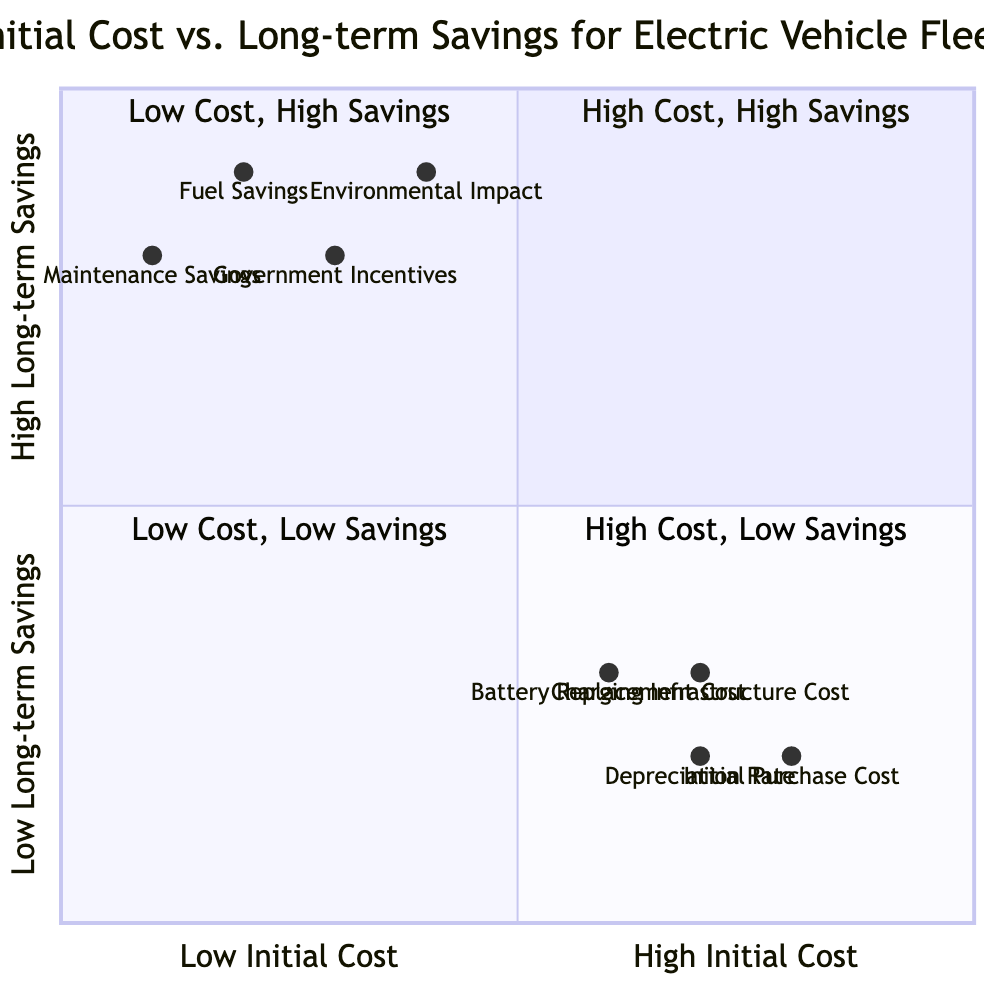What is the position of the Initial Purchase Cost in the chart? The Initial Purchase Cost is located in the Top Left quadrant, indicating it has a high initial cost but lower long-term savings.
Answer: Top Left Which element shows the greatest long-term savings? The Fuel Savings element indicates the highest long-term savings, positioned high in the Bottom Right quadrant.
Answer: Fuel Savings How many elements are in the Top Right quadrant? There are three elements in the Top Right quadrant: Government Incentives, Environmental Impact, and one other element.
Answer: 2 What does the Battery Replacement Cost represent in terms of initial cost and long-term savings? The Battery Replacement Cost is located in the Bottom Left quadrant, signifying it has a high initial cost and low long-term savings.
Answer: Bottom Left Which two elements have the lowest initial costs? The elements with the lowest initial costs are Maintenance Savings and Fuel Savings, both positioned in the Bottom Right quadrant.
Answer: Maintenance Savings and Fuel Savings Is there any element showing a high initial cost but also high long-term savings? Yes, Government Incentives and Environmental Impact are examples that show high long-term savings despite their high individual initial costs.
Answer: No Which element has the lowest long-term savings? The Depreciation Rate is positioned low in the Top Left quadrant, indicative of low long-term savings potential.
Answer: Depreciation Rate How does the average long-term savings compare between the Top Left and Bottom Right quadrants? The Bottom Right quadrant has significantly higher long-term savings (Fuel and Maintenance savings) compared to the Top Left quadrant elements that show lower long-term savings.
Answer: Higher savings in Bottom Right Which element is situated closest to the center of the chart? The Environmental Impact element is closest to the center position between long-term savings and initial cost, indicating a balance between both factors.
Answer: Environmental Impact 